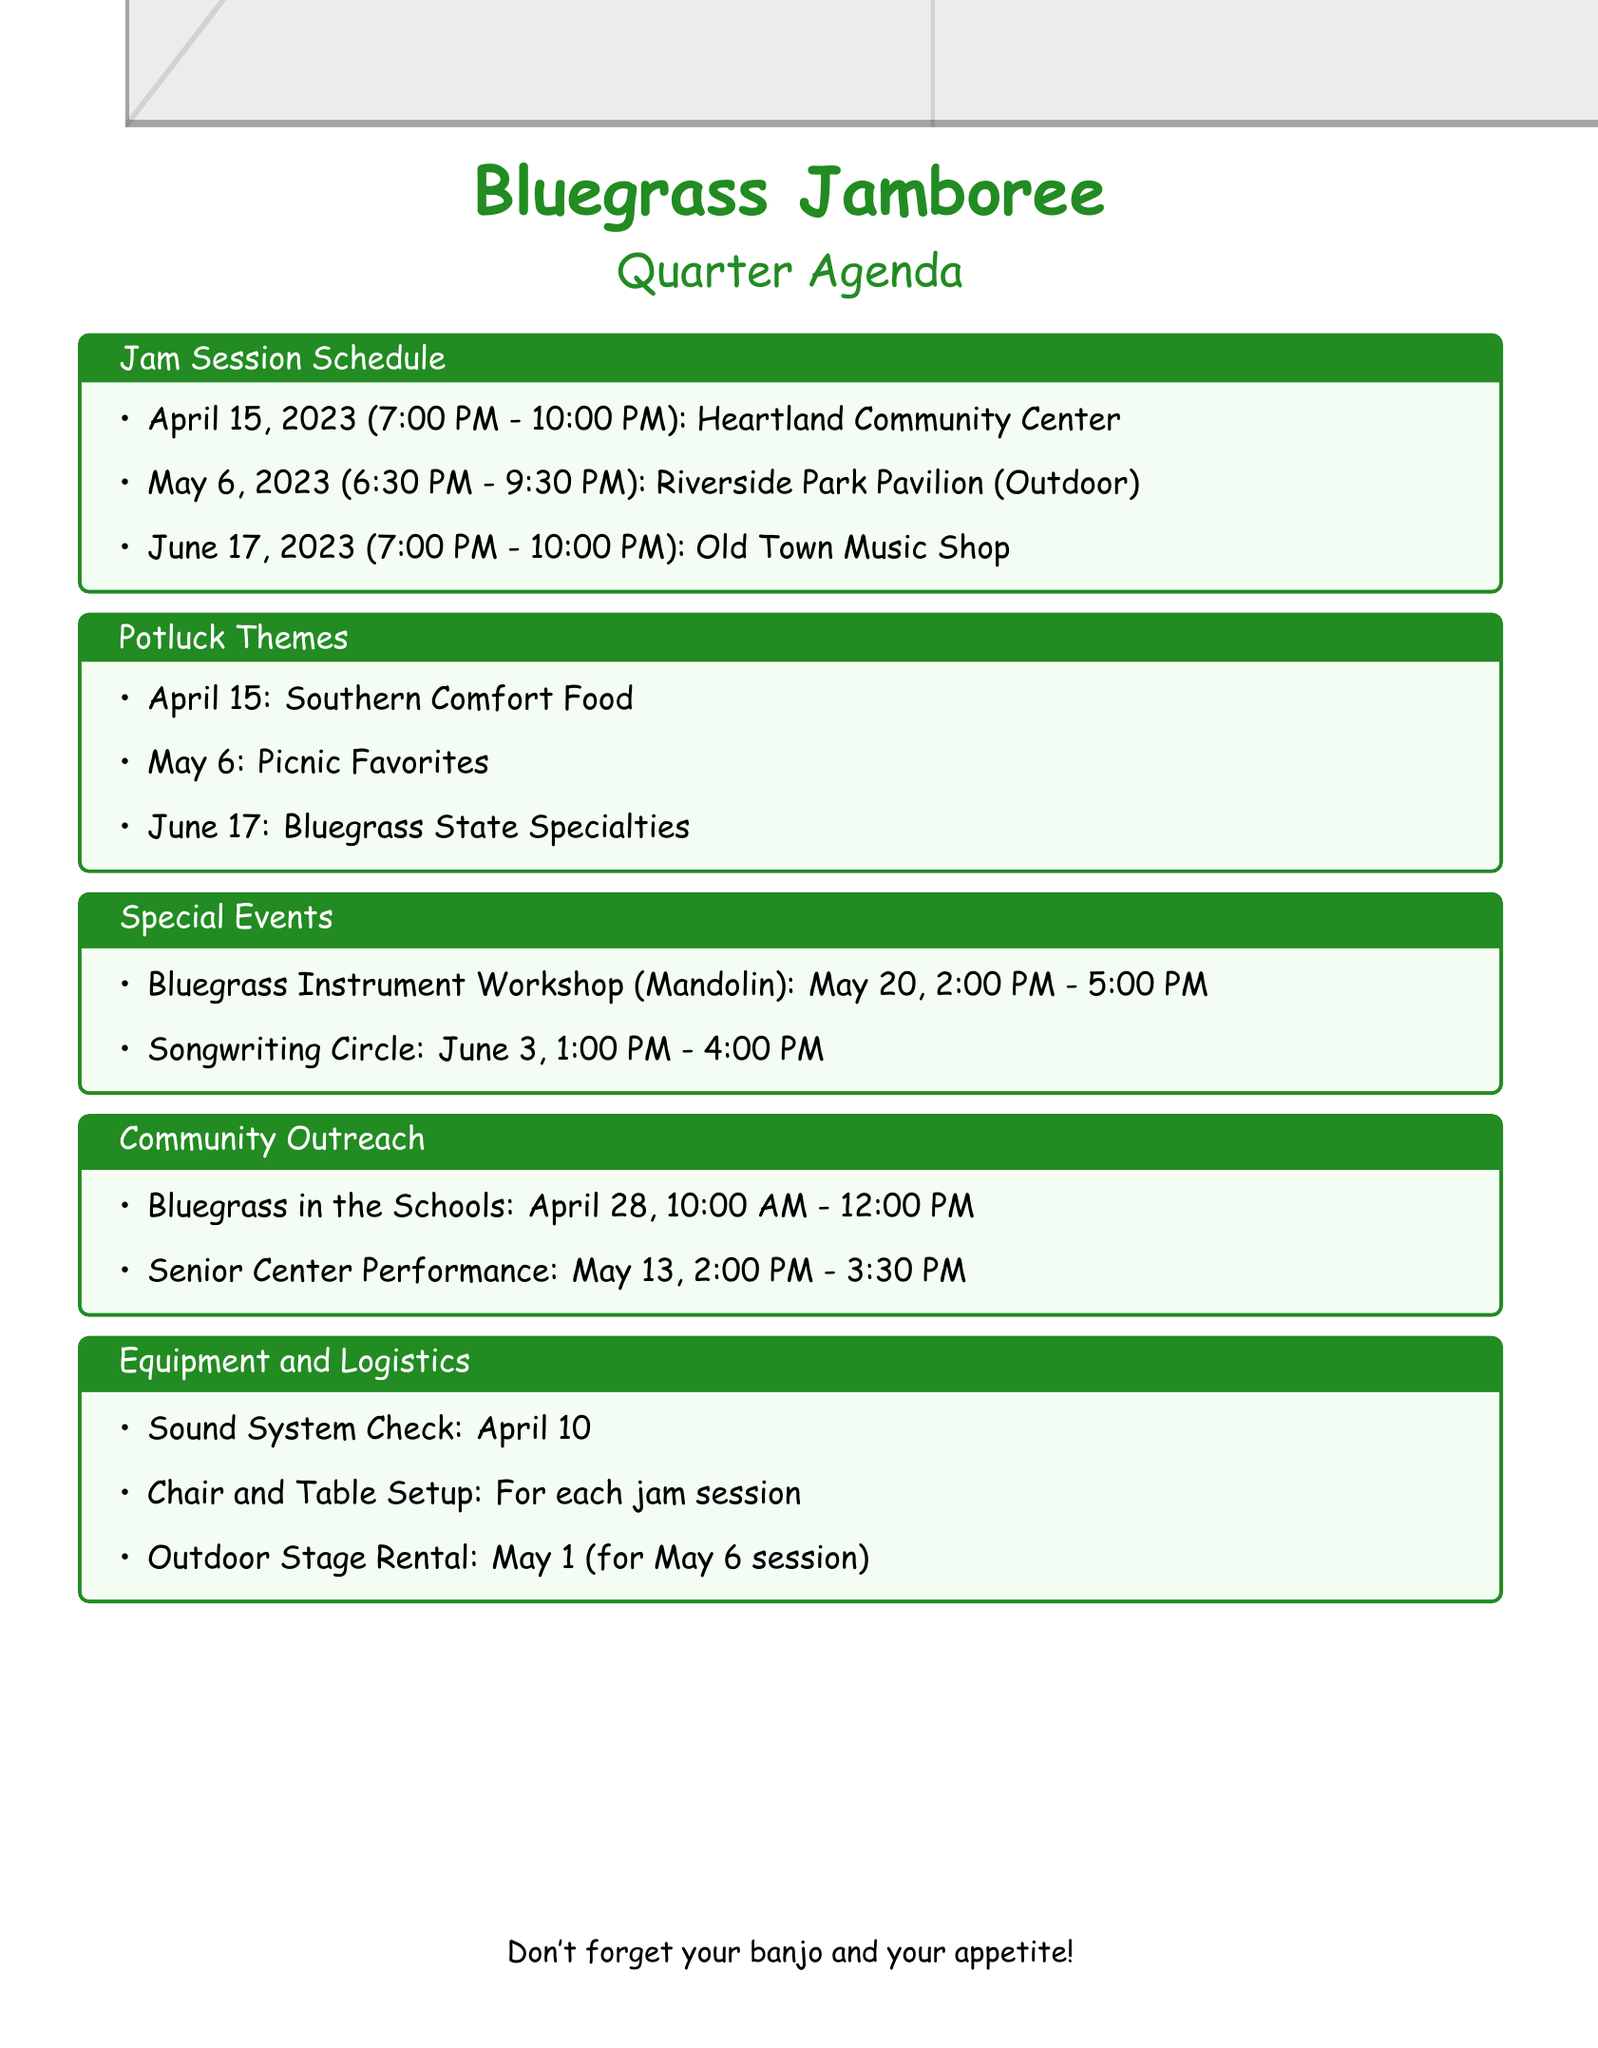What is the date of the first jam session? The first jam session is scheduled for April 15, 2023.
Answer: April 15, 2023 Who is the featured artist for the jam session on June 17? The featured artist for the June 17 jam session is Sarah Johnson, who plays the fiddle.
Answer: Sarah Johnson (fiddle) What is the theme for the potluck on May 6? The theme for the potluck on May 6 is Picnic Favorites.
Answer: Picnic Favorites Who are the volunteers assigned to desserts for the April potluck? The volunteers assigned to desserts for the April potluck are Linda Clark and Robert Green.
Answer: Linda Clark, Robert Green What time does the Bluegrass Instrument Workshop start? The Bluegrass Instrument Workshop starts at 2:00 PM on May 20.
Answer: 2:00 PM How many dish categories are there for the potluck on June 17? There are three dish categories listed for the potluck on June 17: Kentucky Hot Brown, Bourbon-infused Dishes, and Derby Pie and Other Desserts.
Answer: Three What is the location of the jam session on May 6? The location of the jam session on May 6 is Riverside Park Pavilion.
Answer: Riverside Park Pavilion Who is responsible for the sound system check? Tim Andrews is responsible for the sound system check.
Answer: Tim Andrews 